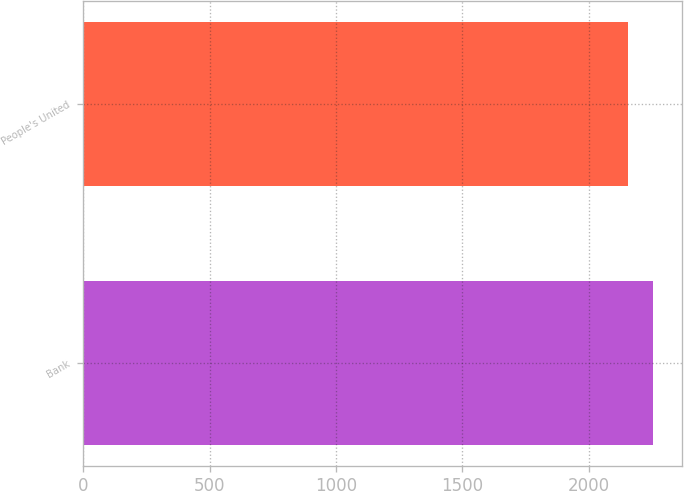<chart> <loc_0><loc_0><loc_500><loc_500><bar_chart><fcel>Bank<fcel>People's United<nl><fcel>2256.8<fcel>2154.6<nl></chart> 